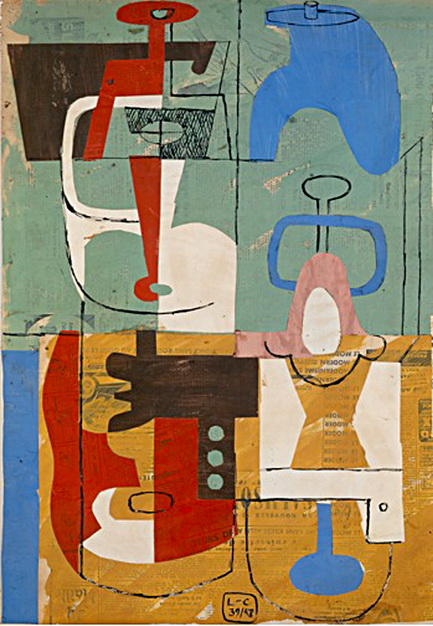If this artwork could tell a story, what would it be about? If this artwork could tell a story, it would narrate a tale of harmony within chaos. The vibrant colors and geometric shapes would represent different elements of life, each with its unique role and significance. The division of the canvas into separate sections would symbolize the diverse experiences and emotions that, while distinct, come together to form a cohesive whole.

The story would be about the balance between structure and spontaneity, illustrating how order can emerge from apparent disorder. The textured background would reflect the ever-present backdrop of tranquility and stability, against which the dynamic and vibrant foreground elements play out a narrative of growth, conflict, and resolution. This tale would celebrate the beauty of diversity and the interconnectedness of all aspects of existence. 